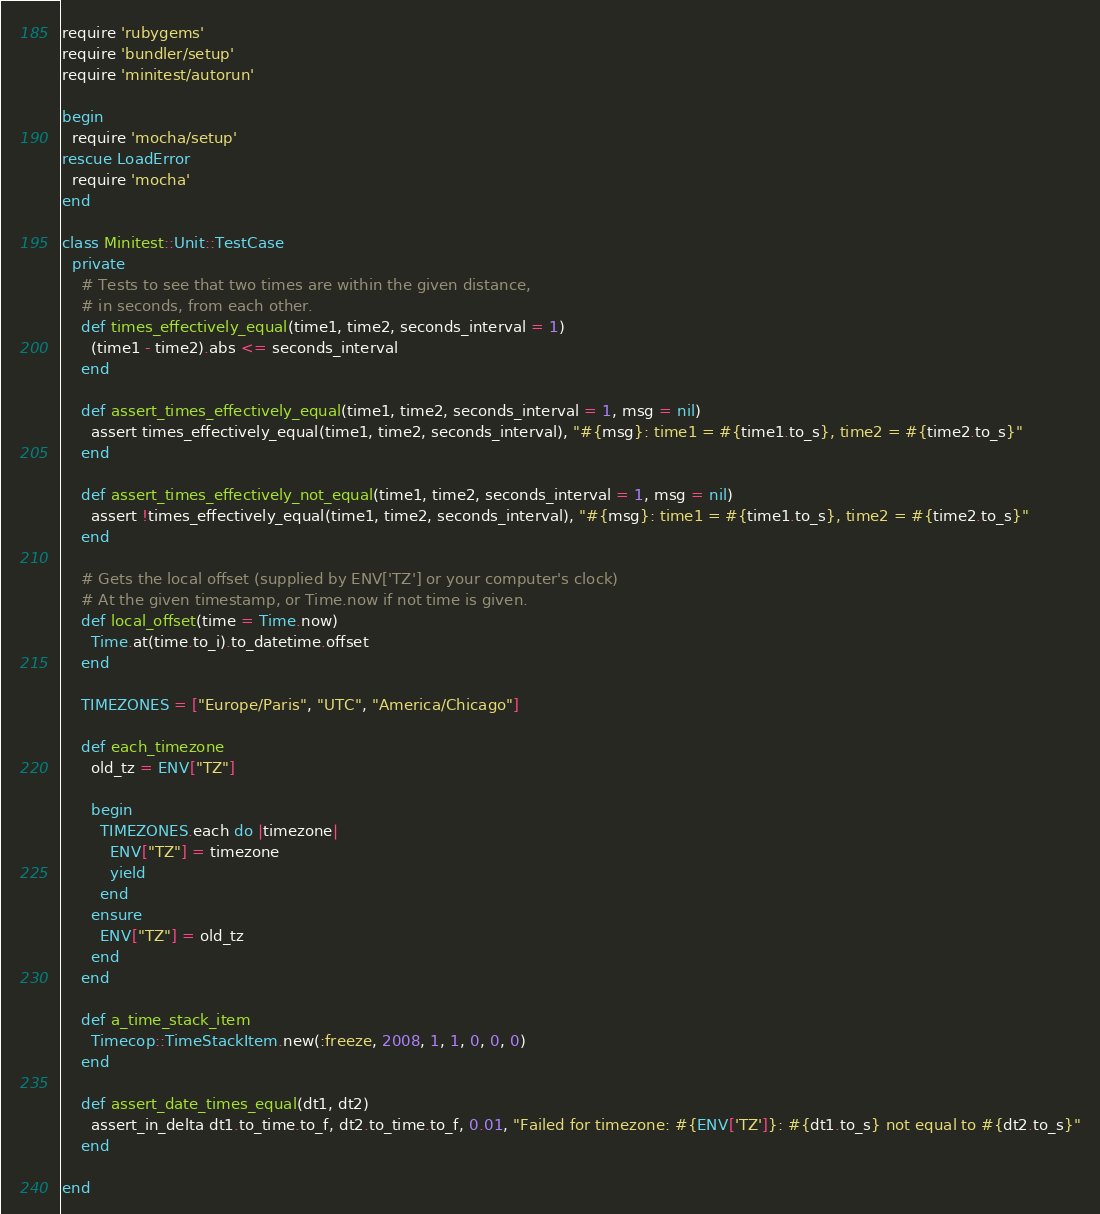Convert code to text. <code><loc_0><loc_0><loc_500><loc_500><_Ruby_>require 'rubygems'
require 'bundler/setup'
require 'minitest/autorun'

begin
  require 'mocha/setup'
rescue LoadError
  require 'mocha'
end

class Minitest::Unit::TestCase
  private
    # Tests to see that two times are within the given distance,
    # in seconds, from each other.
    def times_effectively_equal(time1, time2, seconds_interval = 1)
      (time1 - time2).abs <= seconds_interval
    end

    def assert_times_effectively_equal(time1, time2, seconds_interval = 1, msg = nil)
      assert times_effectively_equal(time1, time2, seconds_interval), "#{msg}: time1 = #{time1.to_s}, time2 = #{time2.to_s}"
    end

    def assert_times_effectively_not_equal(time1, time2, seconds_interval = 1, msg = nil)
      assert !times_effectively_equal(time1, time2, seconds_interval), "#{msg}: time1 = #{time1.to_s}, time2 = #{time2.to_s}"
    end

    # Gets the local offset (supplied by ENV['TZ'] or your computer's clock)
    # At the given timestamp, or Time.now if not time is given.
    def local_offset(time = Time.now)
      Time.at(time.to_i).to_datetime.offset
    end

    TIMEZONES = ["Europe/Paris", "UTC", "America/Chicago"]

    def each_timezone
      old_tz = ENV["TZ"]

      begin
        TIMEZONES.each do |timezone|
          ENV["TZ"] = timezone
          yield
        end
      ensure
        ENV["TZ"] = old_tz
      end
    end

    def a_time_stack_item
      Timecop::TimeStackItem.new(:freeze, 2008, 1, 1, 0, 0, 0)
    end

    def assert_date_times_equal(dt1, dt2)
      assert_in_delta dt1.to_time.to_f, dt2.to_time.to_f, 0.01, "Failed for timezone: #{ENV['TZ']}: #{dt1.to_s} not equal to #{dt2.to_s}"
    end

end
</code> 